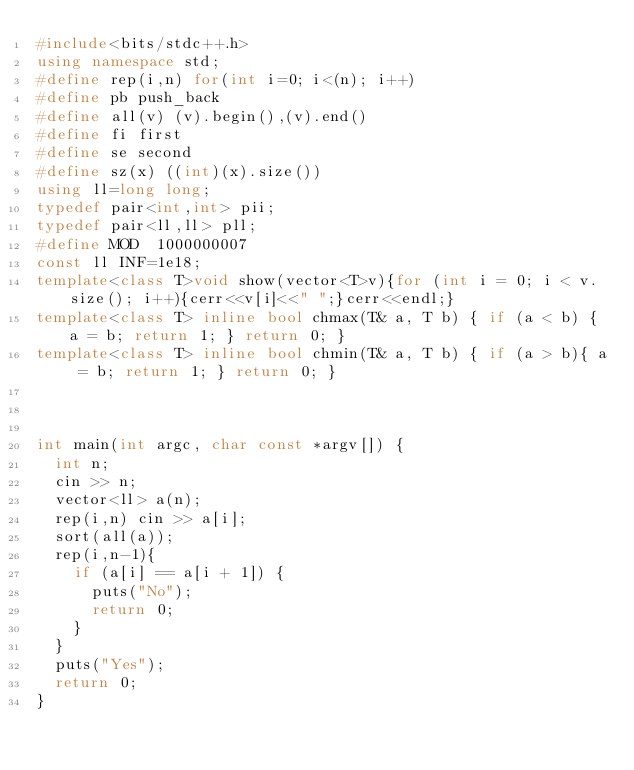<code> <loc_0><loc_0><loc_500><loc_500><_C++_>#include<bits/stdc++.h>
using namespace std;
#define rep(i,n) for(int i=0; i<(n); i++)
#define pb push_back
#define all(v) (v).begin(),(v).end()
#define fi first
#define se second
#define sz(x) ((int)(x).size())
using ll=long long;
typedef pair<int,int> pii;
typedef pair<ll,ll> pll;
#define MOD  1000000007
const ll INF=1e18;
template<class T>void show(vector<T>v){for (int i = 0; i < v.size(); i++){cerr<<v[i]<<" ";}cerr<<endl;}
template<class T> inline bool chmax(T& a, T b) { if (a < b) { a = b; return 1; } return 0; }
template<class T> inline bool chmin(T& a, T b) { if (a > b){ a = b; return 1; } return 0; }



int main(int argc, char const *argv[]) {
  int n;
  cin >> n;
  vector<ll> a(n);
  rep(i,n) cin >> a[i];
  sort(all(a));
  rep(i,n-1){
    if (a[i] == a[i + 1]) {
      puts("No");
      return 0;
    }
  }
  puts("Yes");
  return 0;
}</code> 